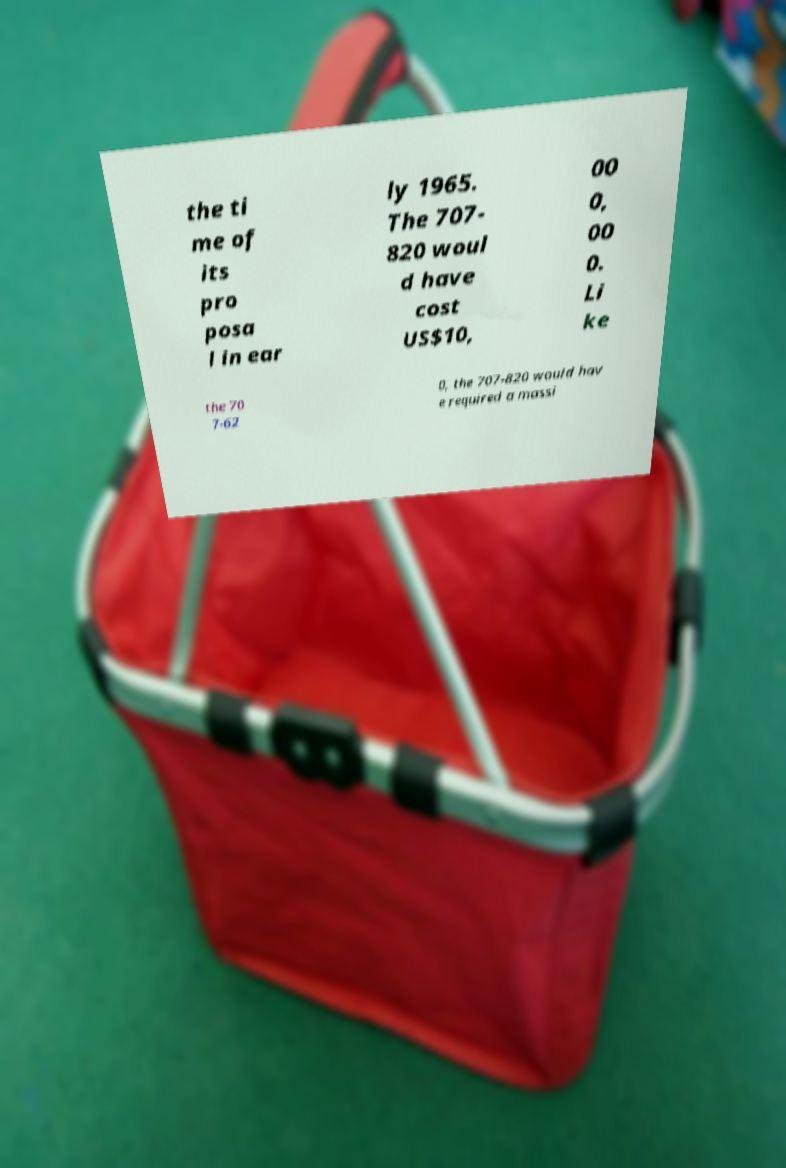Could you extract and type out the text from this image? the ti me of its pro posa l in ear ly 1965. The 707- 820 woul d have cost US$10, 00 0, 00 0. Li ke the 70 7-62 0, the 707-820 would hav e required a massi 